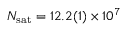<formula> <loc_0><loc_0><loc_500><loc_500>{ N _ { s a t } } = 1 2 . 2 ( 1 ) \times 1 0 ^ { 7 }</formula> 